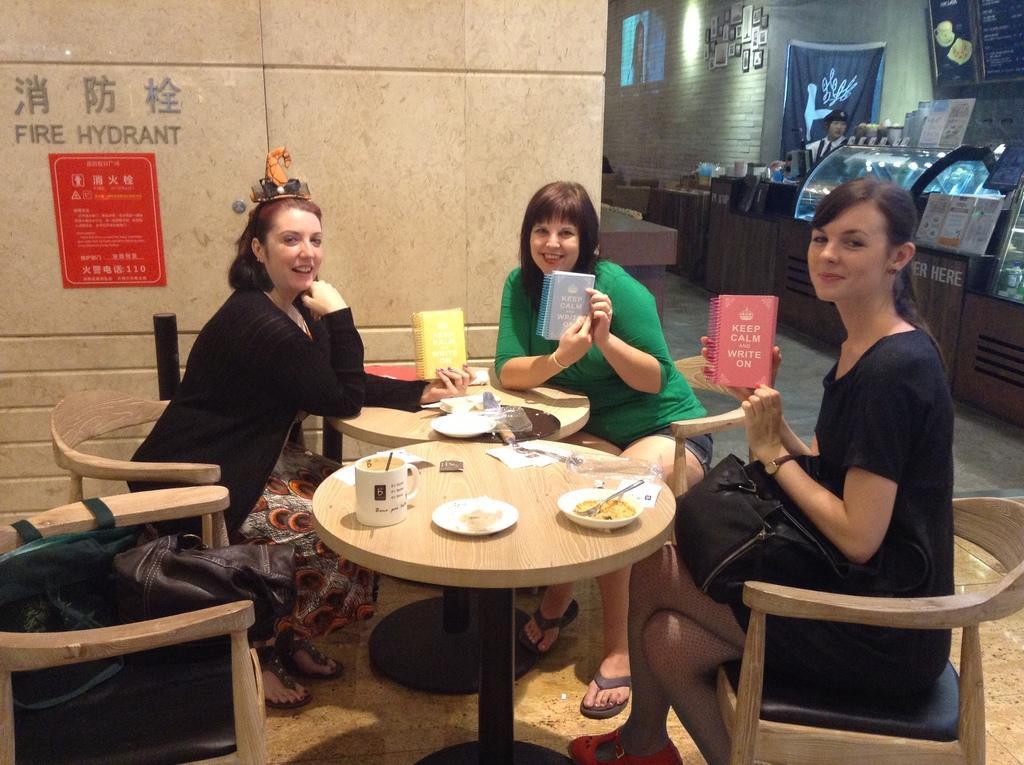Describe this image in one or two sentences. This picture shows women Seated on chairs and holding a book in their hands. 